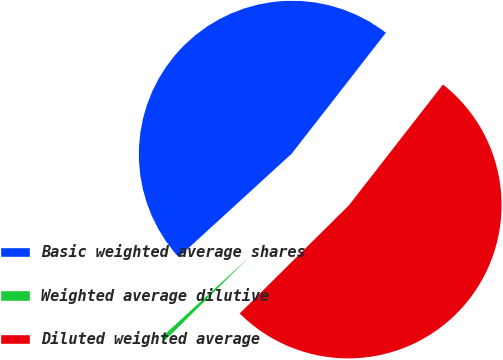<chart> <loc_0><loc_0><loc_500><loc_500><pie_chart><fcel>Basic weighted average shares<fcel>Weighted average dilutive<fcel>Diluted weighted average<nl><fcel>47.32%<fcel>0.63%<fcel>52.05%<nl></chart> 